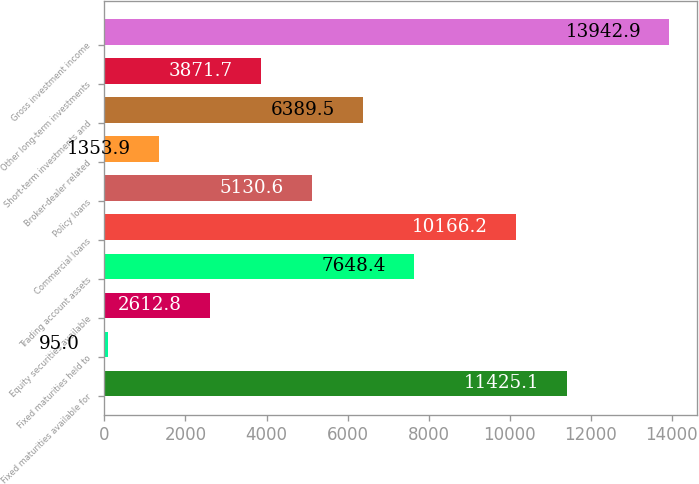<chart> <loc_0><loc_0><loc_500><loc_500><bar_chart><fcel>Fixed maturities available for<fcel>Fixed maturities held to<fcel>Equity securities available<fcel>Trading account assets<fcel>Commercial loans<fcel>Policy loans<fcel>Broker-dealer related<fcel>Short-term investments and<fcel>Other long-term investments<fcel>Gross investment income<nl><fcel>11425.1<fcel>95<fcel>2612.8<fcel>7648.4<fcel>10166.2<fcel>5130.6<fcel>1353.9<fcel>6389.5<fcel>3871.7<fcel>13942.9<nl></chart> 